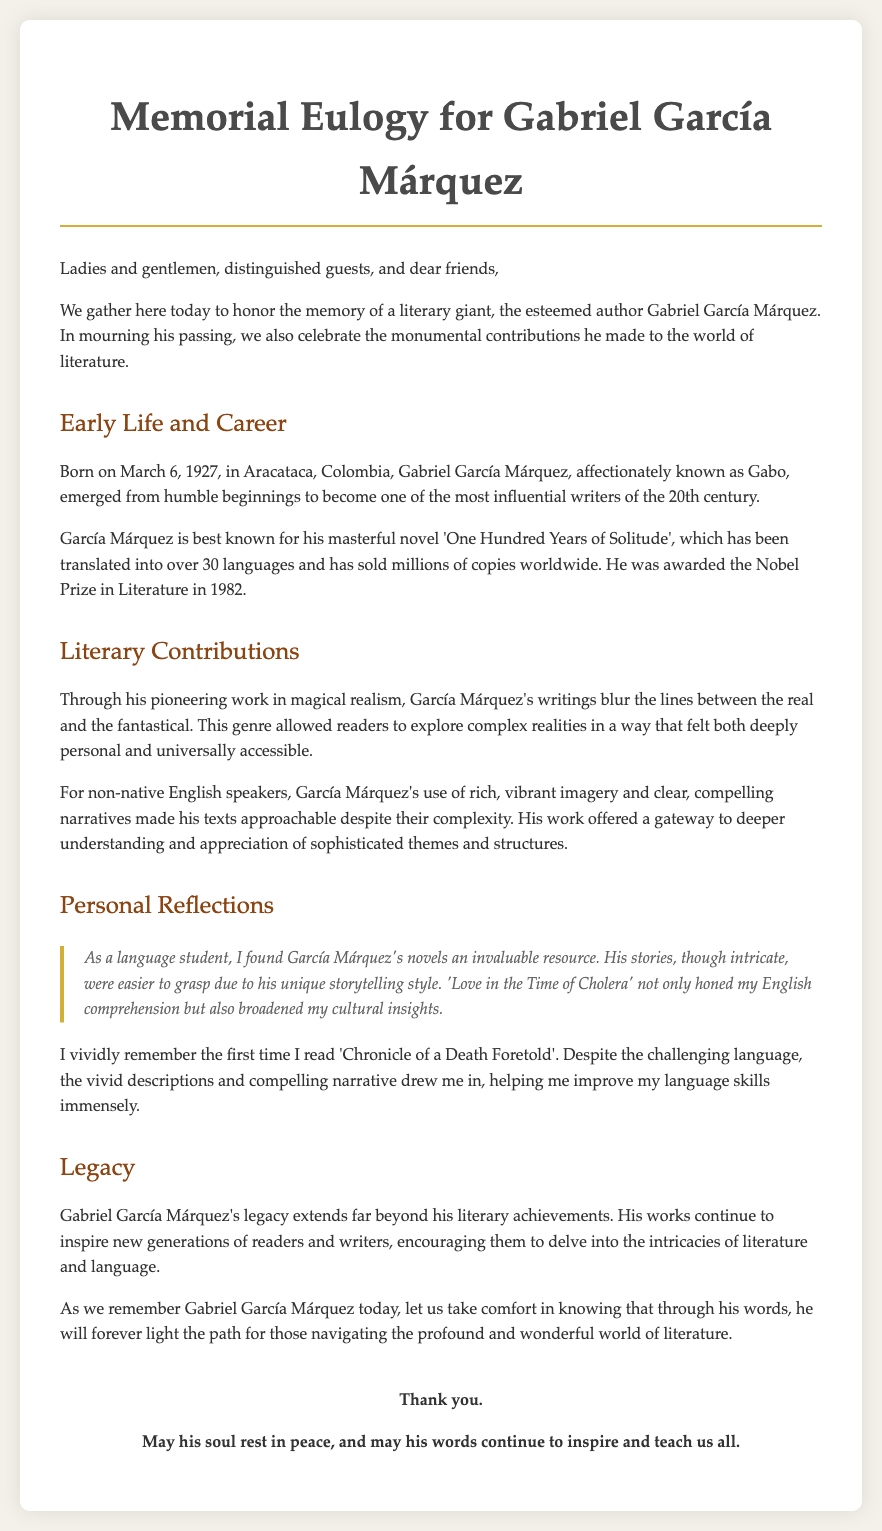what is the full name of the author being honored? The document mentions that the memorial eulogy is for Gabriel García Márquez, a renowned author.
Answer: Gabriel García Márquez when was Gabriel García Márquez born? The document states that he was born on March 6, 1927, in Aracataca, Colombia.
Answer: March 6, 1927 what is the title of García Márquez's most famous novel? The eulogy references 'One Hundred Years of Solitude' as his masterful novel.
Answer: One Hundred Years of Solitude what literary genre did García Márquez pioneer? The document indicates that he is known for his pioneering work in magical realism.
Answer: magical realism how did García Márquez's work help non-native speakers? The text explains that his rich imagery and clear narratives made his texts approachable for non-native speakers.
Answer: approachable what prestigious award did García Márquez receive in 1982? The eulogy mentions that he was awarded the Nobel Prize in Literature.
Answer: Nobel Prize in Literature how did the speaker describe García Márquez's influence on language students? The speaker reflects that his novels were invaluable resources for language comprehension and cultural insights.
Answer: invaluable resources what personal experience does the speaker share about reading García Márquez? The speaker recalls reading 'Chronicle of a Death Foretold' despite the challenging language, which improved their skills.
Answer: improved their skills how does the eulogy conclude? The closing section asks for comfort in his words that will light the path for literature explorers.
Answer: light the path for those navigating literature 